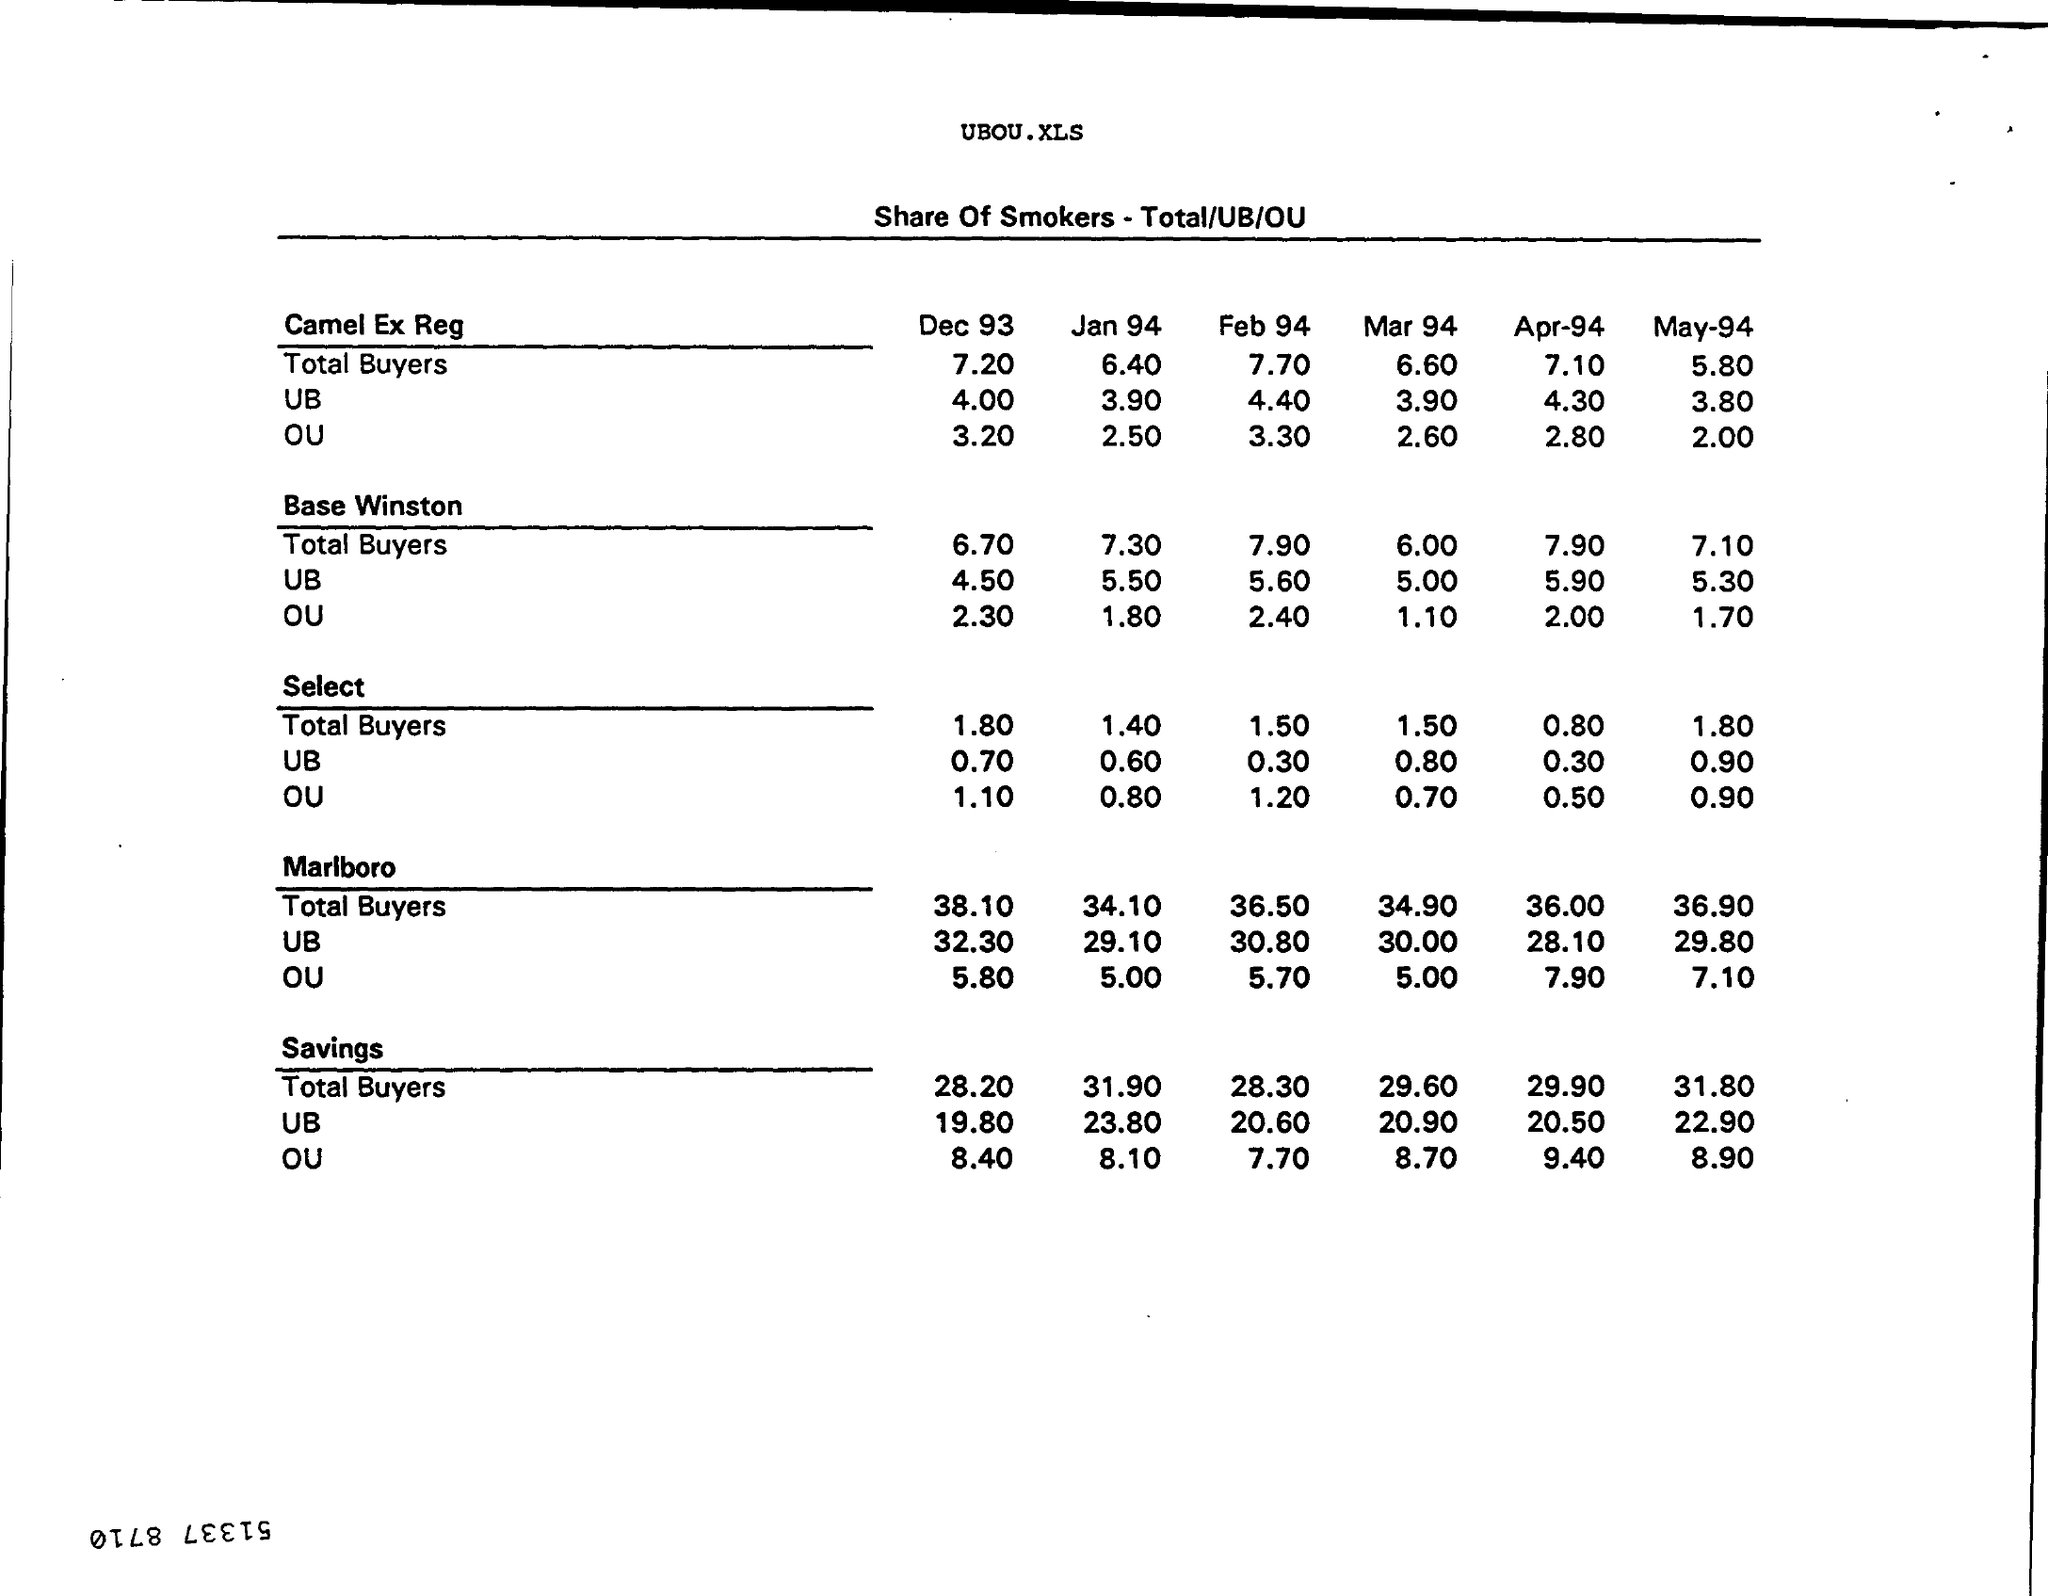Give some essential details in this illustration. The total buyers for Camel Ex Reg for December 1993 was 7.20. What is the Office of Under Secretary for Select for December 93? It is 1.10. The OU, or official usable quantity, for Base Winston for December 1993 is 2.30. The total buyers for Marlboro for January 1994 was 34.10. The total buyers for base Winston for December 1993 was 6.70. 